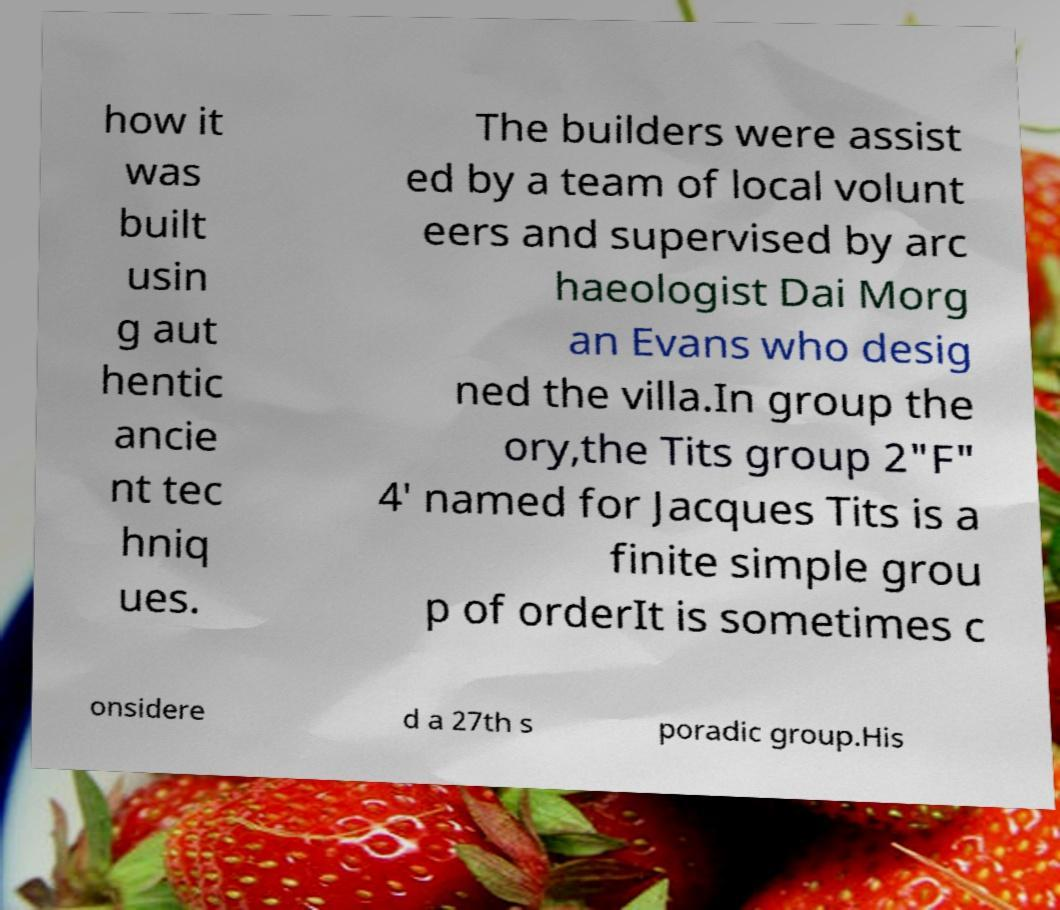There's text embedded in this image that I need extracted. Can you transcribe it verbatim? how it was built usin g aut hentic ancie nt tec hniq ues. The builders were assist ed by a team of local volunt eers and supervised by arc haeologist Dai Morg an Evans who desig ned the villa.In group the ory,the Tits group 2"F" 4′ named for Jacques Tits is a finite simple grou p of orderIt is sometimes c onsidere d a 27th s poradic group.His 